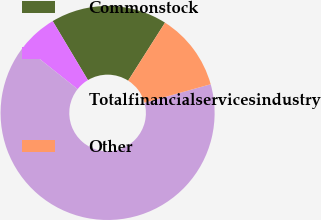Convert chart to OTSL. <chart><loc_0><loc_0><loc_500><loc_500><pie_chart><fcel>Commonstock<fcel>Unnamed: 1<fcel>Totalfinancialservicesindustry<fcel>Other<nl><fcel>17.59%<fcel>5.74%<fcel>65.01%<fcel>11.66%<nl></chart> 